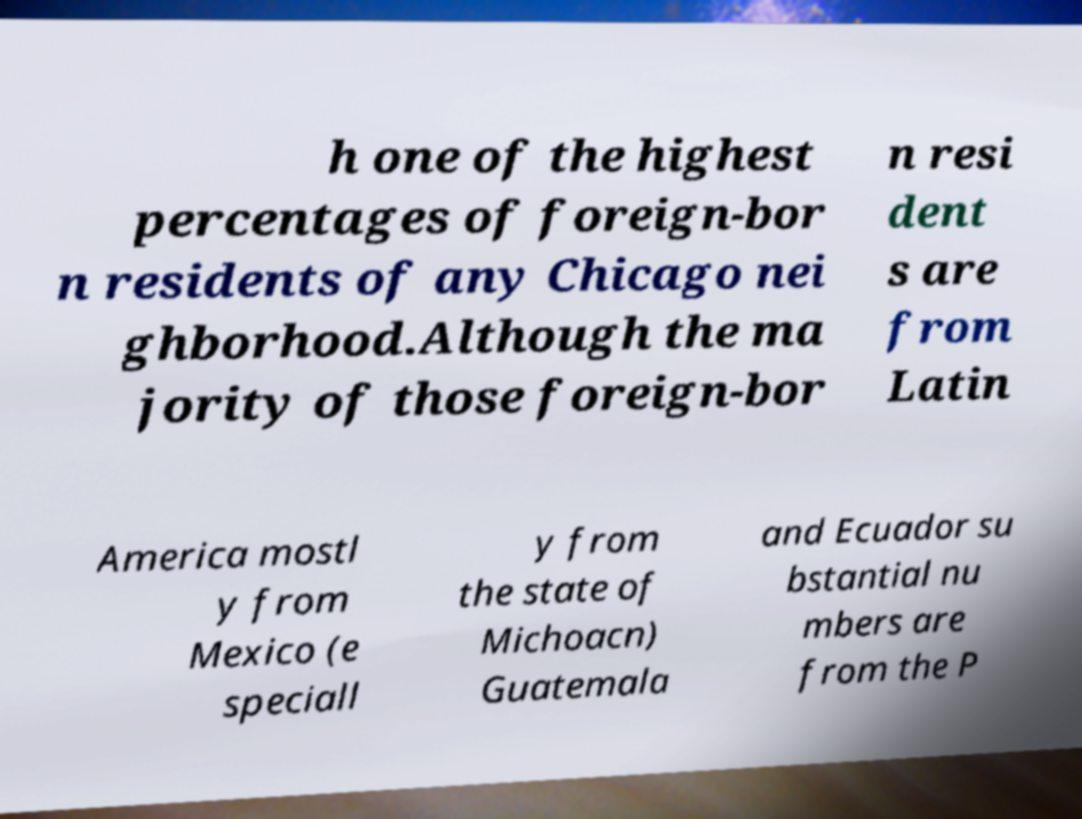Could you assist in decoding the text presented in this image and type it out clearly? h one of the highest percentages of foreign-bor n residents of any Chicago nei ghborhood.Although the ma jority of those foreign-bor n resi dent s are from Latin America mostl y from Mexico (e speciall y from the state of Michoacn) Guatemala and Ecuador su bstantial nu mbers are from the P 